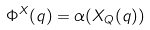Convert formula to latex. <formula><loc_0><loc_0><loc_500><loc_500>\label l { E \colon e x a c t m m } \Phi ^ { X } ( q ) = \alpha ( X _ { Q } ( q ) )</formula> 